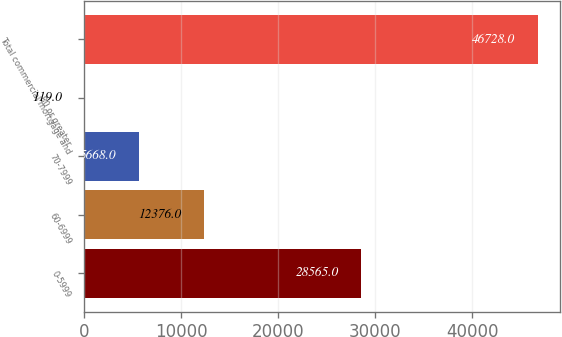<chart> <loc_0><loc_0><loc_500><loc_500><bar_chart><fcel>0-5999<fcel>60-6999<fcel>70-7999<fcel>80 or greater<fcel>Total commercial mortgage and<nl><fcel>28565<fcel>12376<fcel>5668<fcel>119<fcel>46728<nl></chart> 